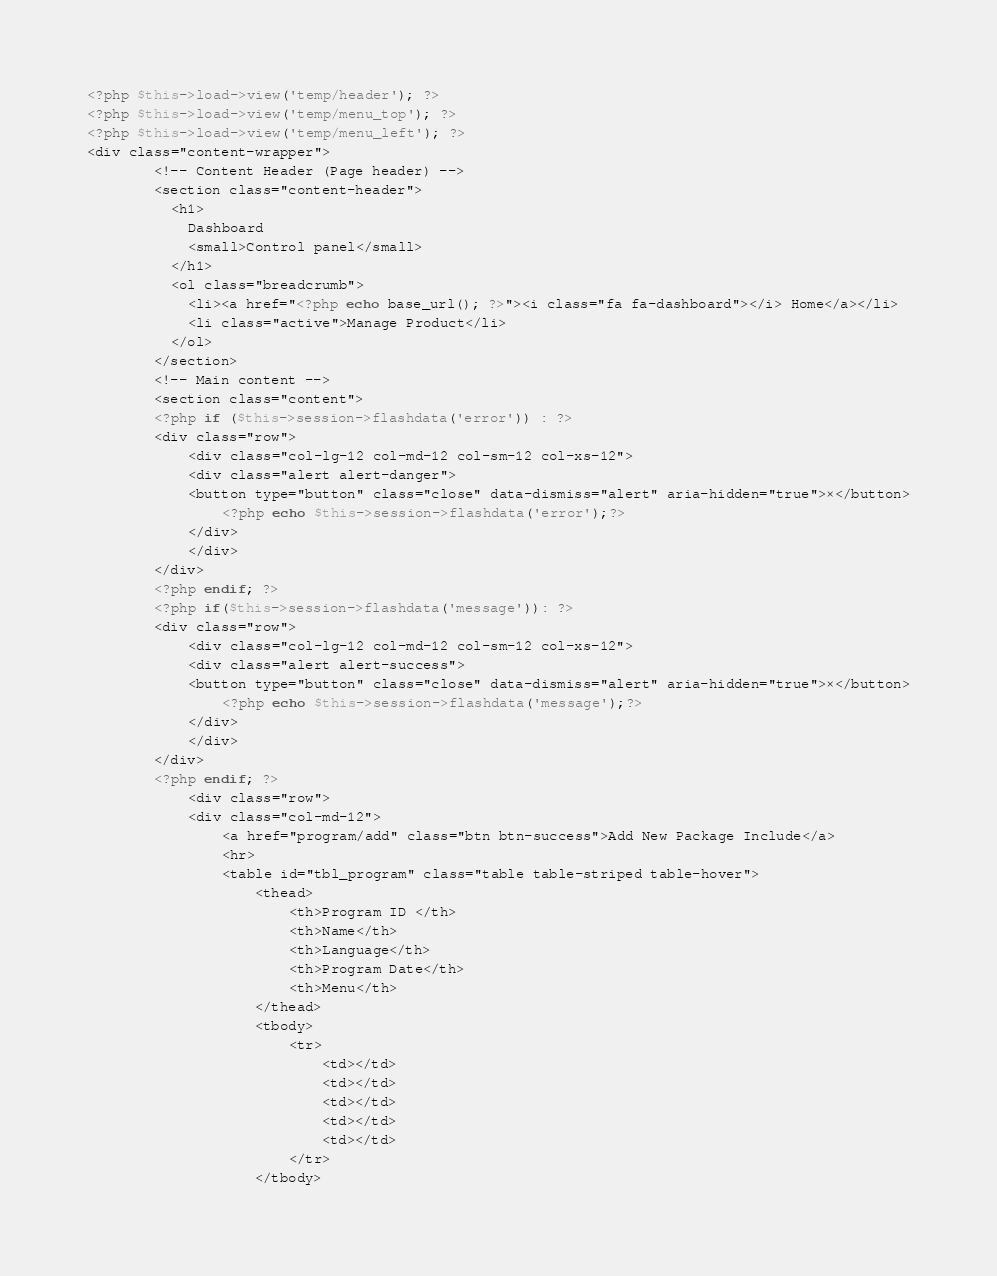<code> <loc_0><loc_0><loc_500><loc_500><_PHP_><?php $this->load->view('temp/header'); ?>
<?php $this->load->view('temp/menu_top'); ?>
<?php $this->load->view('temp/menu_left'); ?>
<div class="content-wrapper">
        <!-- Content Header (Page header) -->
        <section class="content-header">
          <h1>
            Dashboard
            <small>Control panel</small>
          </h1>
          <ol class="breadcrumb">
            <li><a href="<?php echo base_url(); ?>"><i class="fa fa-dashboard"></i> Home</a></li>
            <li class="active">Manage Product</li>
          </ol>
        </section>
        <!-- Main content -->
        <section class="content">
        <?php if ($this->session->flashdata('error')) : ?>
        <div class="row">
            <div class="col-lg-12 col-md-12 col-sm-12 col-xs-12">
            <div class="alert alert-danger">
            <button type="button" class="close" data-dismiss="alert" aria-hidden="true">×</button>
                <?php echo $this->session->flashdata('error');?>
            </div>
            </div>
        </div>
        <?php endif; ?>
        <?php if($this->session->flashdata('message')): ?>
        <div class="row">
            <div class="col-lg-12 col-md-12 col-sm-12 col-xs-12">
            <div class="alert alert-success">
            <button type="button" class="close" data-dismiss="alert" aria-hidden="true">×</button>
                <?php echo $this->session->flashdata('message');?>
            </div>
            </div>
        </div>
        <?php endif; ?>
			<div class="row">
            <div class="col-md-12">
				<a href="program/add" class="btn btn-success">Add New Package Include</a>
                <hr>
                <table id="tbl_program" class="table table-striped table-hover">
                    <thead>
                        <th>Program ID </th>
                        <th>Name</th>
                        <th>Language</th>
                        <th>Program Date</th>
                        <th>Menu</th>
                    </thead>
                    <tbody>
                        <tr>
                            <td></td>
                            <td></td>
                            <td></td>
                            <td></td>
                            <td></td>
                        </tr>
                    </tbody></code> 